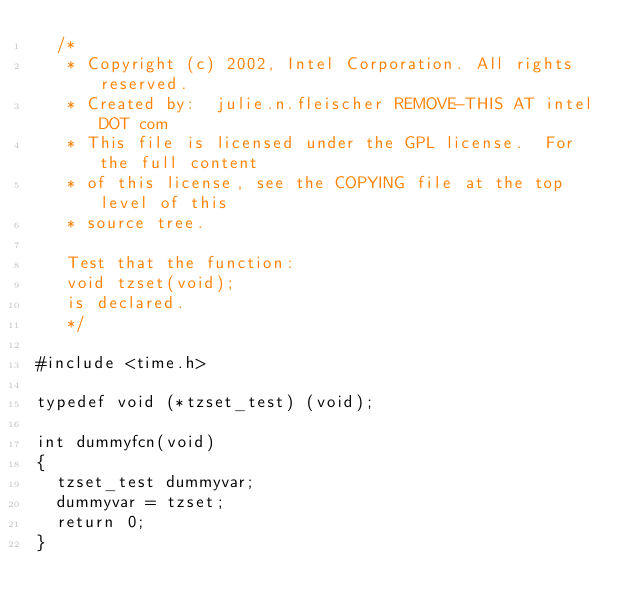<code> <loc_0><loc_0><loc_500><loc_500><_C_>  /*
   * Copyright (c) 2002, Intel Corporation. All rights reserved.
   * Created by:  julie.n.fleischer REMOVE-THIS AT intel DOT com
   * This file is licensed under the GPL license.  For the full content
   * of this license, see the COPYING file at the top level of this
   * source tree.

   Test that the function:
   void tzset(void);
   is declared.
   */

#include <time.h>

typedef void (*tzset_test) (void);

int dummyfcn(void)
{
	tzset_test dummyvar;
	dummyvar = tzset;
	return 0;
}
</code> 